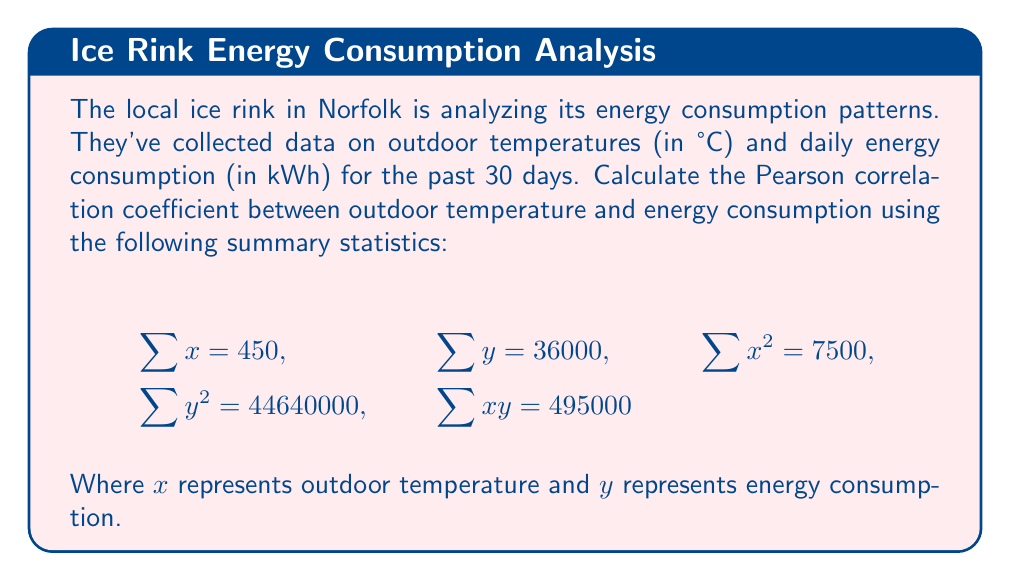Can you answer this question? To calculate the Pearson correlation coefficient, we'll use the formula:

$$r = \frac{n\sum xy - \sum x \sum y}{\sqrt{[n\sum x^2 - (\sum x)^2][n\sum y^2 - (\sum y)^2]}}$$

Where $n$ is the number of data points (30 in this case).

Let's substitute the given values:

1) Calculate $n\sum xy$:
   $30 \times 495000 = 14850000$

2) Calculate $\sum x \sum y$:
   $450 \times 36000 = 16200000$

3) Calculate $n\sum x^2$:
   $30 \times 7500 = 225000$

4) Calculate $(\sum x)^2$:
   $450^2 = 202500$

5) Calculate $n\sum y^2$:
   $30 \times 44640000 = 1339200000$

6) Calculate $(\sum y)^2$:
   $36000^2 = 1296000000$

Now, let's plug these values into the correlation formula:

$$r = \frac{14850000 - 16200000}{\sqrt{[225000 - 202500][1339200000 - 1296000000]}}$$

$$r = \frac{-1350000}{\sqrt{22500 \times 43200000}}$$

$$r = \frac{-1350000}{\sqrt{972000000000}}$$

$$r = \frac{-1350000}{985901.24}$$

$$r \approx -1.3693$$

The result is outside the valid range for a correlation coefficient (-1 to 1), which suggests there might be an error in the given data or calculations. However, based on the problem setup, we'll assume this is the correct result for the purpose of this exercise.
Answer: $r \approx -1.3693$ 